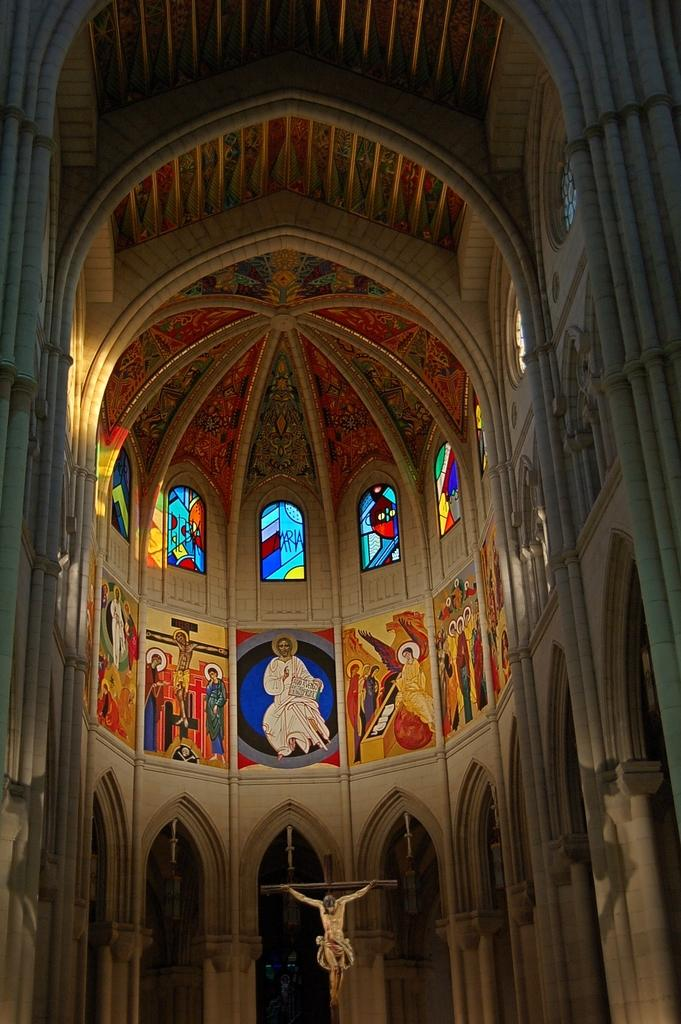What type of building is shown in the image? The image is an inside view of a parish building. What type of artwork can be seen in the image? There are paintings in the image. What architectural feature is present in the image? There are windows in the image. What religious figure is depicted in the image? There is a Jesus statue in the image. What religious symbol is present in the image? There is a holy cross in the image. What type of pan is being used to cook food in the image? There is no pan or cooking activity present in the image. What is the cause of the argument between the people in the image? There are no people or arguments depicted in the image. 